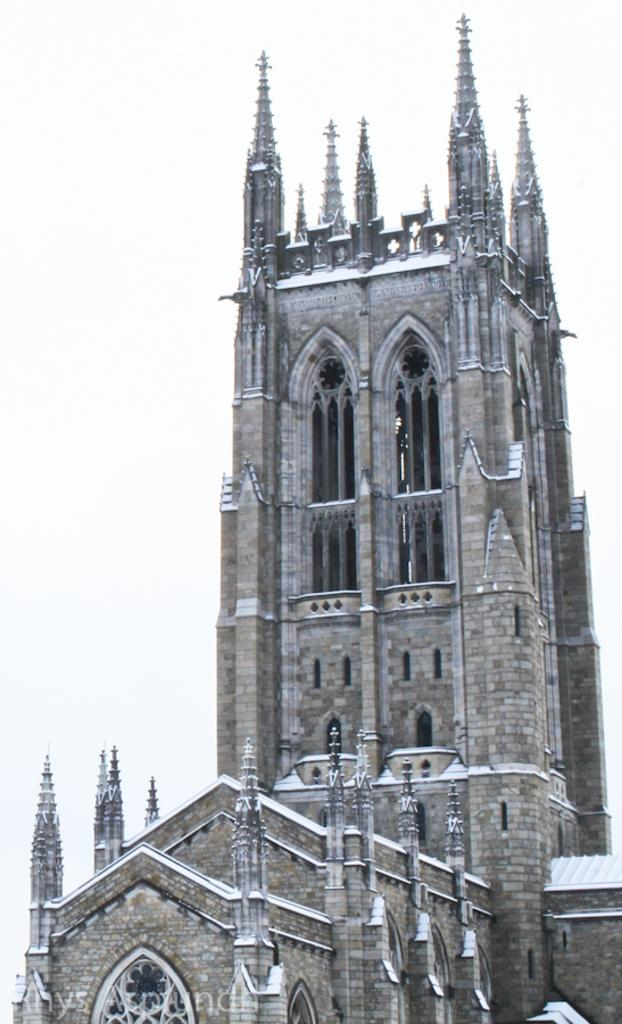What is the main subject of the picture? The main subject of the picture is a building. What are some features of the building? The building has windows and pillars. Can you tell me how many goats are standing on top of the building in the image? There are no goats present on the building in the image. What type of soup is being served in the building's dining area in the image? There is no dining area or soup visible in the image; it only features a building with windows and pillars. 